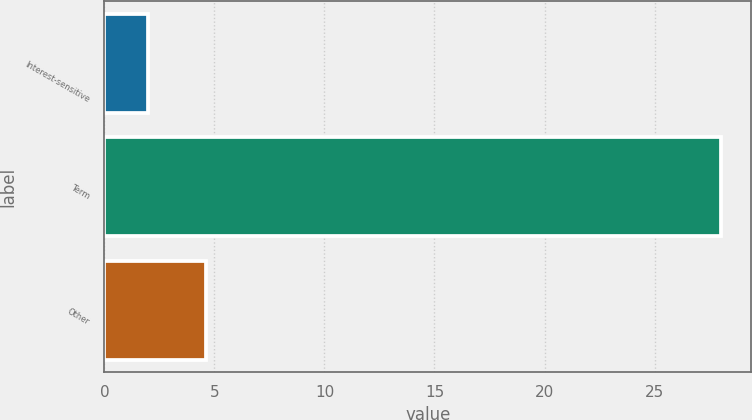Convert chart to OTSL. <chart><loc_0><loc_0><loc_500><loc_500><bar_chart><fcel>Interest-sensitive<fcel>Term<fcel>Other<nl><fcel>2<fcel>28<fcel>4.6<nl></chart> 